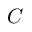Convert formula to latex. <formula><loc_0><loc_0><loc_500><loc_500>C</formula> 